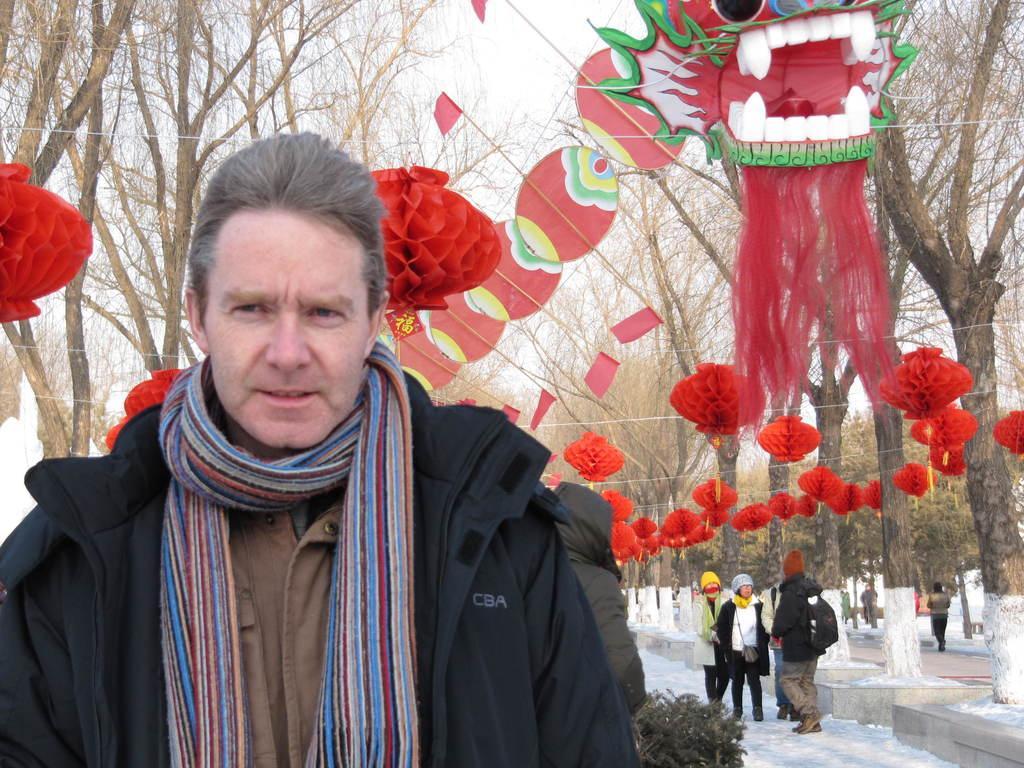Please provide a concise description of this image. In the background we can see the sky, trees and we can see the decoration with decorative items. In this picture we can see the people, snow and the road. This picture is mainly highlighted with a man wearing a jacket and a scarf. 